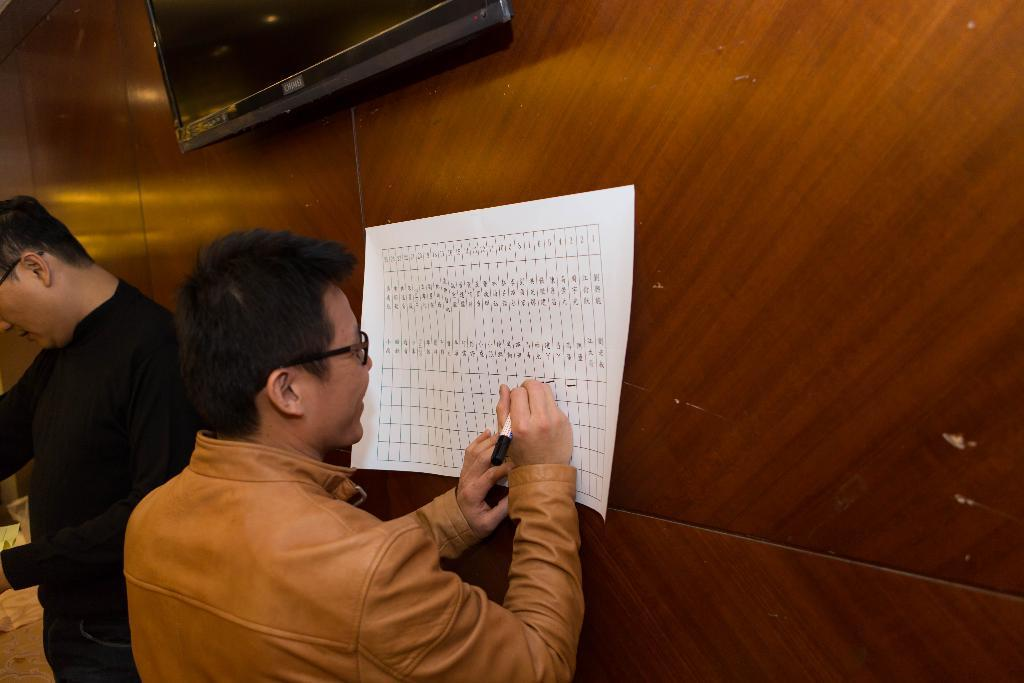How many people are in the image? There are two people in the image. What is one person doing with a paper? One person is holding a paper and writing on it. What can be seen in the image besides the people and paper? There is a monitor in the image. Can you describe the appearance of the monitor's background? The monitor has a wooden background. What type of quiver is visible on the wooden background of the monitor? There is no quiver present on the wooden background of the monitor in the image. What kind of yam is being used as a prop in the image? There is no yam present in the image. 